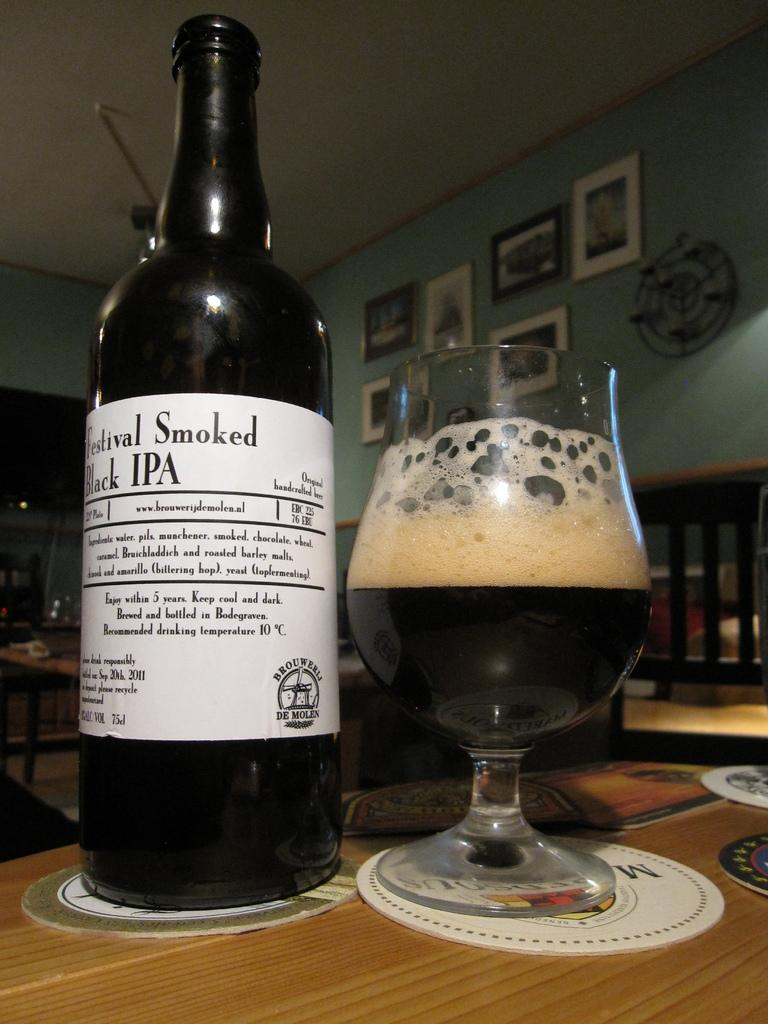Provide a one-sentence caption for the provided image. Some wine with the title Festival Smoked on the label. 